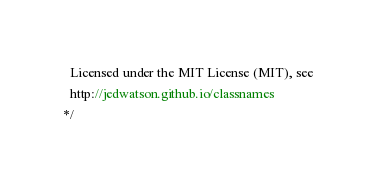Convert code to text. <code><loc_0><loc_0><loc_500><loc_500><_JavaScript_>  Licensed under the MIT License (MIT), see
  http://jedwatson.github.io/classnames
*/</code> 